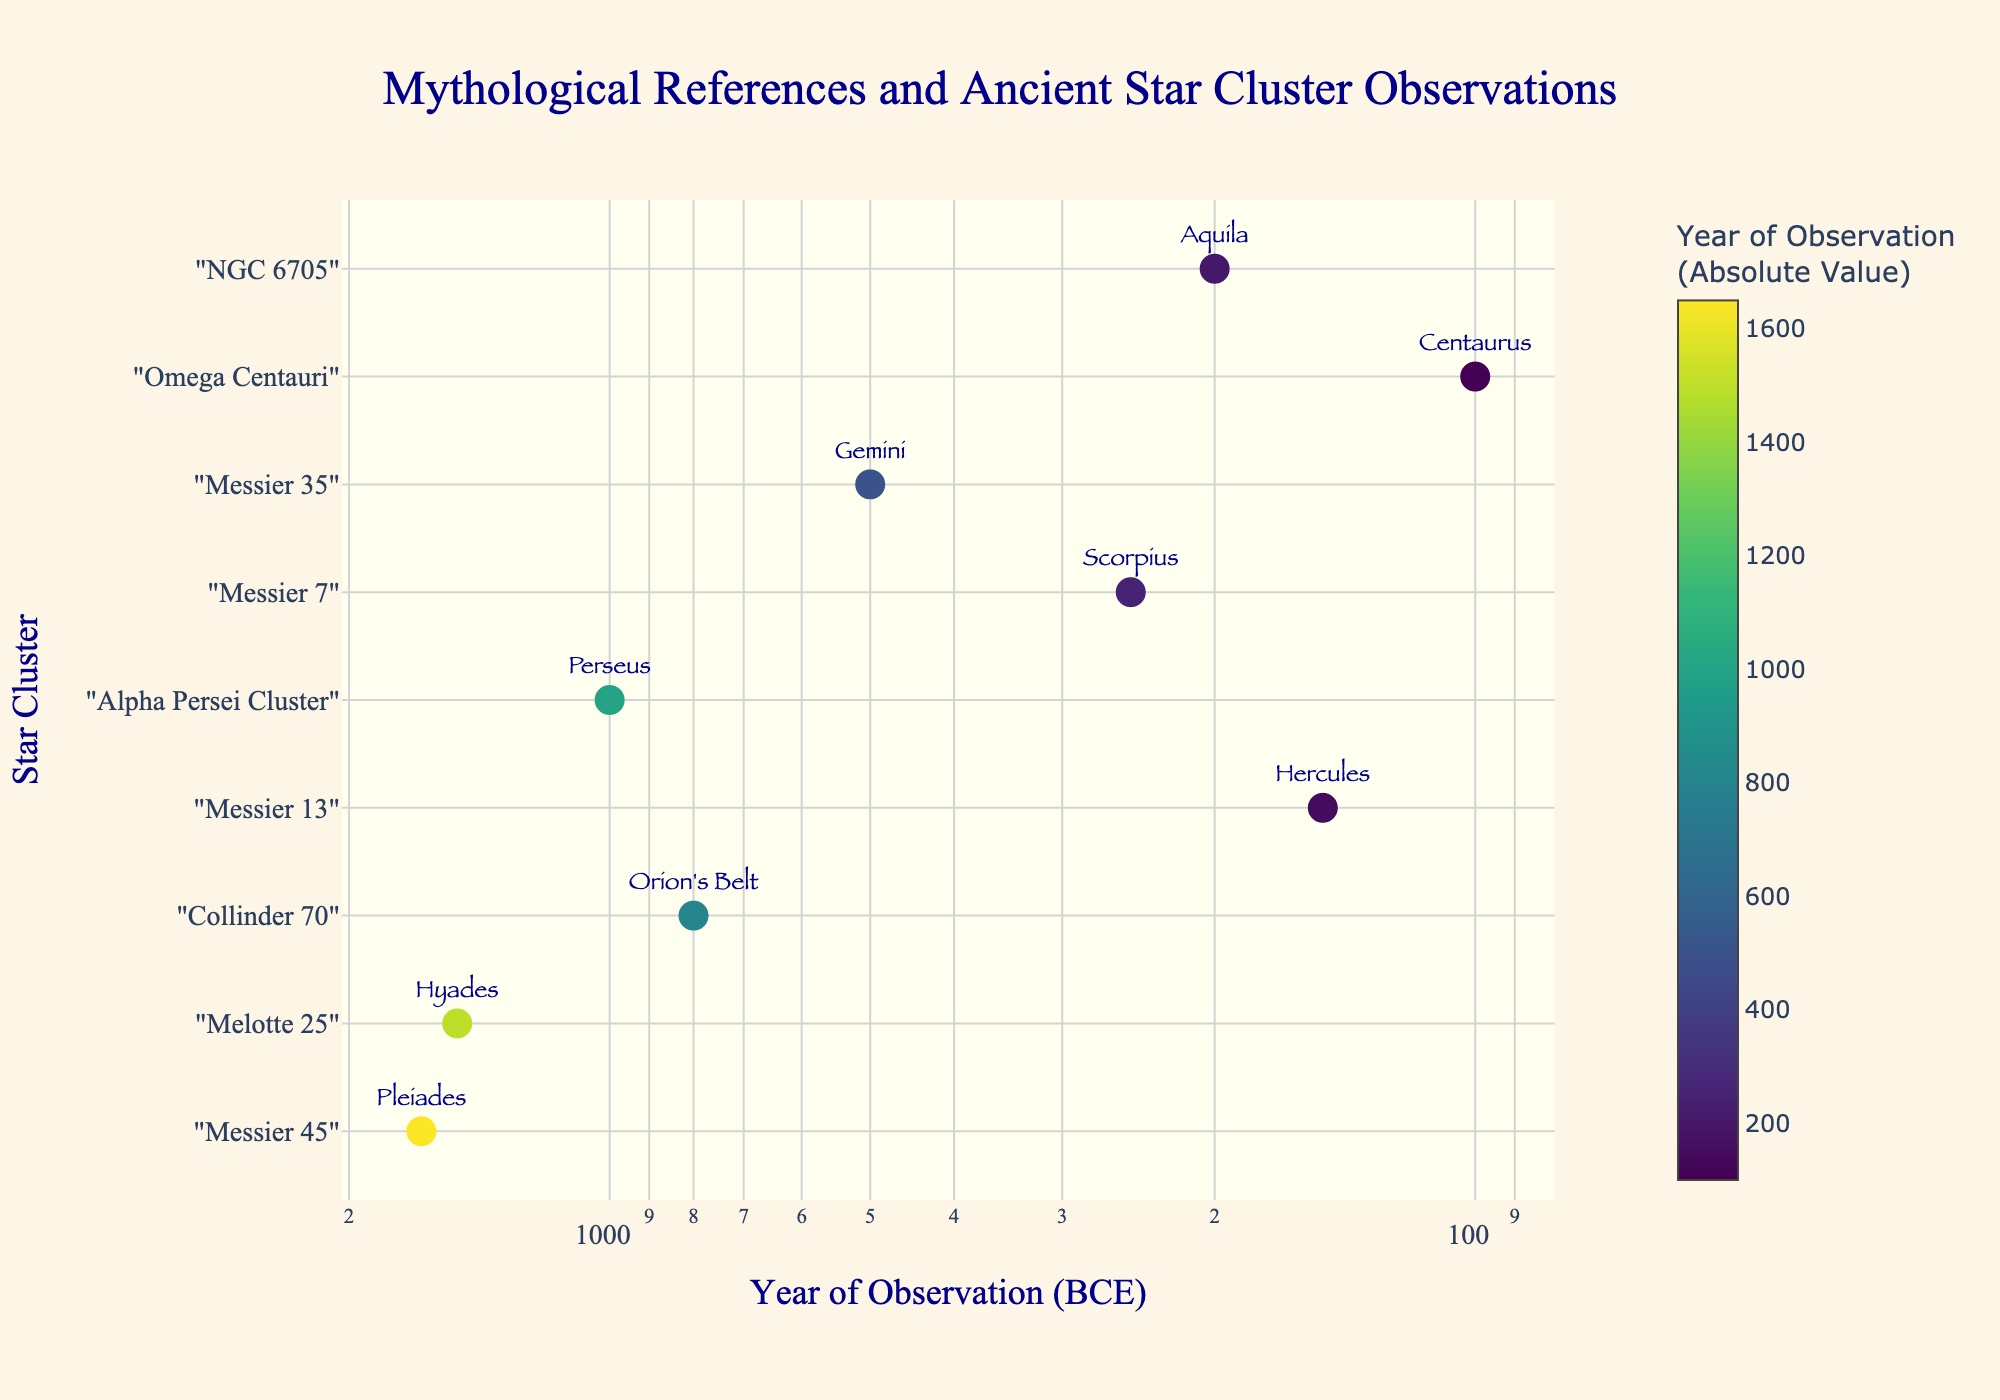What is the title of the scatter plot? The title of the scatter plot is displayed at the top center of the figure.
Answer: Mythological References and Ancient Star Cluster Observations How many star clusters are represented in the scatter plot? Each unique y-value corresponds to a star cluster, which can be counted visually.
Answer: 9 Which star cluster was documented first by ancient civilizations? The star cluster documented first would have the smallest x-value (largest negative number year). Based on the log scale, this data point would be furthest to the right.
Answer: Messier 45 (Pleiades) What is the color scale used for in the scatter plot? The color scale represents the absolute values of the years of observation. This can be inferred from the color bar provided next to the scatter plot.
Answer: Year of Observation (Absolute Value) In which BCE year was the Alpha Persei Cluster documented? By hovering over or looking at the annotation text of the data point corresponding to "Perseus," we find the year documented.
Answer: -1000 Which mythological reference corresponds to the star cluster documented in -150 BCE? Find the x-value corresponding to -150 on the log scale and look for the associated mythological reference in the hover text.
Answer: Hercules What is the range of years (in BCE) during which these star clusters were documented? The range can be found by identifying the minimum and maximum x-values on the log scale, and reading the corresponding BCE values.
Answer: -1650 to -100 Which star cluster's observation falls closest to 500 BCE? Find the x-value around the 500 BCE mark and check the nearest data point by comparing hover text information.
Answer: Messier 35 (Gemini) How does the observation year of Aquila compare to that of Centaurus? Look at the x-values of Aquila and Centaurus on the log scale and note that Aquila has a higher x-value, making it more recent compared to Centaurus.
Answer: Earlier Is the documentation of mythological references chronologically clustered or spread out? By observing the scatter plot, determine if the x-values (years) are closely packed together or widely spread across the x-axis.
Answer: Spread out 